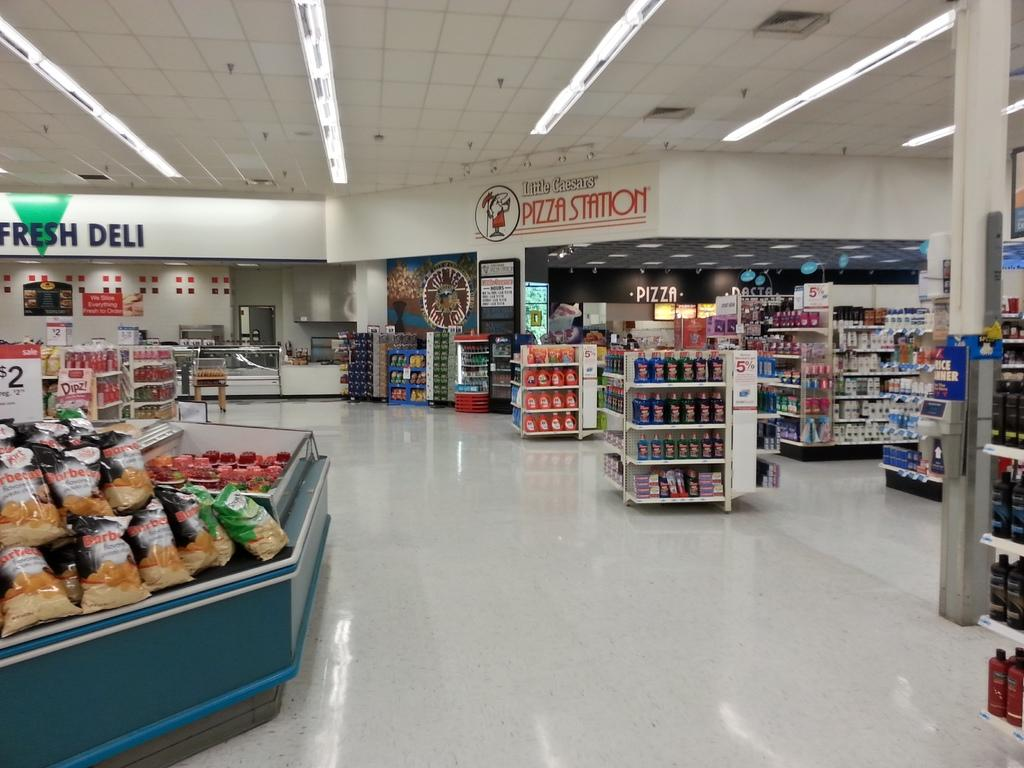<image>
Provide a brief description of the given image. A Little Cesear's pizza station is at the back of a grocery store. 